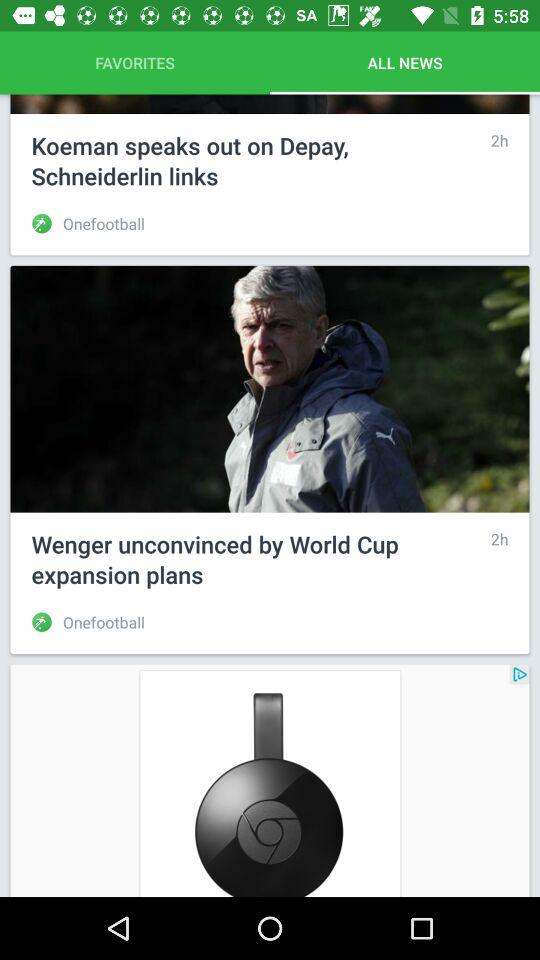Which tab is selected? The selected tab is "ALL NEWS". 